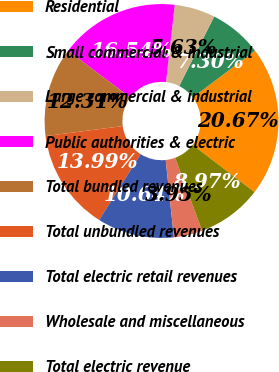Convert chart to OTSL. <chart><loc_0><loc_0><loc_500><loc_500><pie_chart><fcel>Residential<fcel>Small commercial & industrial<fcel>Large commercial & industrial<fcel>Public authorities & electric<fcel>Total bundled revenues<fcel>Total unbundled revenues<fcel>Total electric retail revenues<fcel>Wholesale and miscellaneous<fcel>Total electric revenue<nl><fcel>20.67%<fcel>7.3%<fcel>5.63%<fcel>16.54%<fcel>12.31%<fcel>13.99%<fcel>10.64%<fcel>3.95%<fcel>8.97%<nl></chart> 